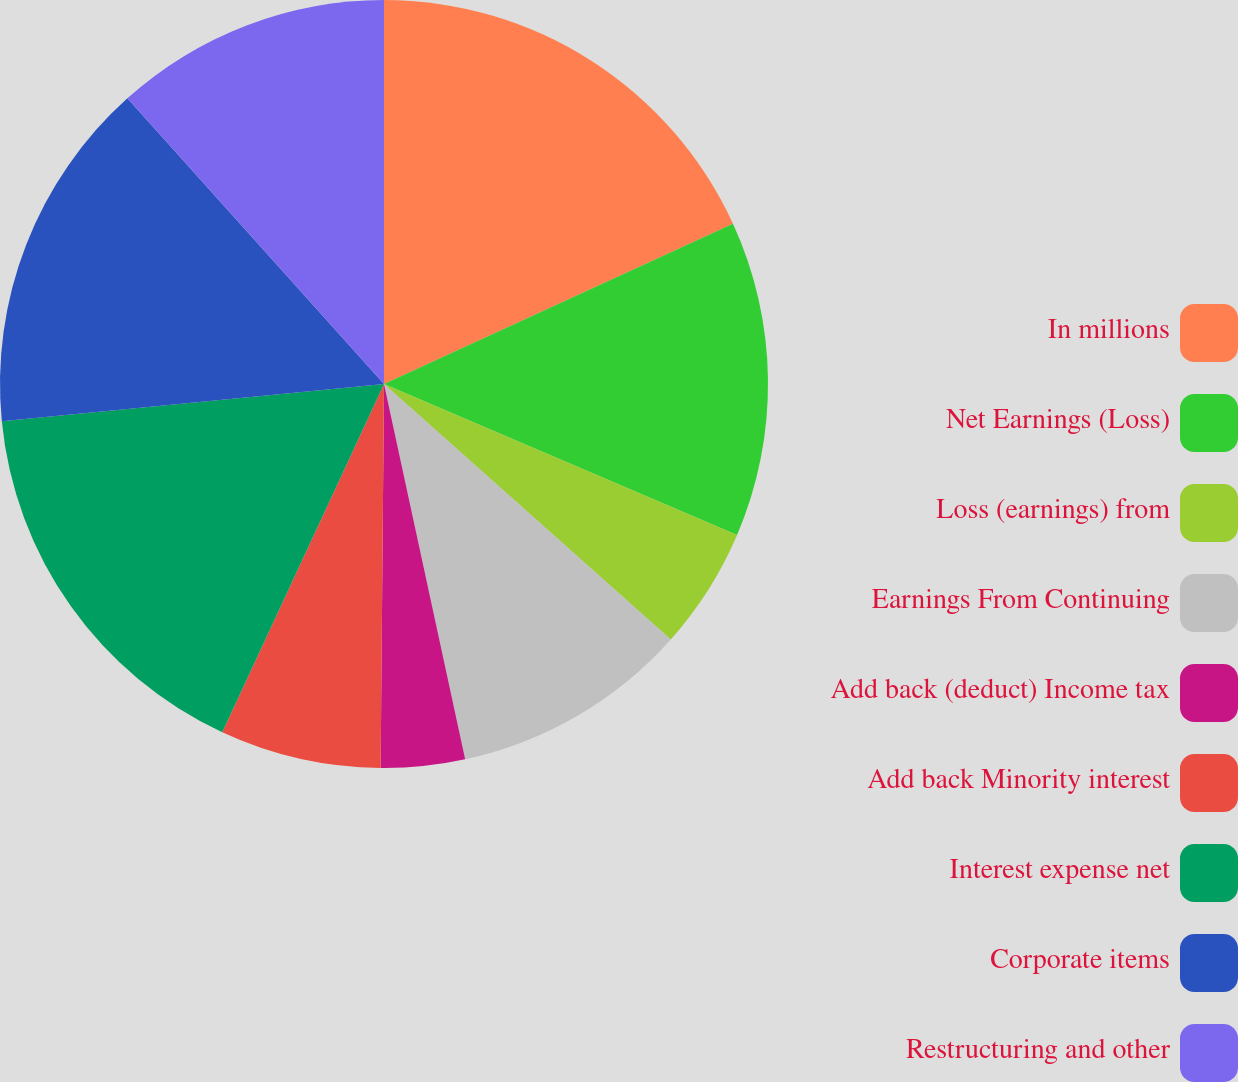Convert chart to OTSL. <chart><loc_0><loc_0><loc_500><loc_500><pie_chart><fcel>In millions<fcel>Net Earnings (Loss)<fcel>Loss (earnings) from<fcel>Earnings From Continuing<fcel>Add back (deduct) Income tax<fcel>Add back Minority interest<fcel>Interest expense net<fcel>Corporate items<fcel>Restructuring and other<nl><fcel>18.15%<fcel>13.28%<fcel>5.15%<fcel>10.03%<fcel>3.53%<fcel>6.78%<fcel>16.53%<fcel>14.9%<fcel>11.65%<nl></chart> 